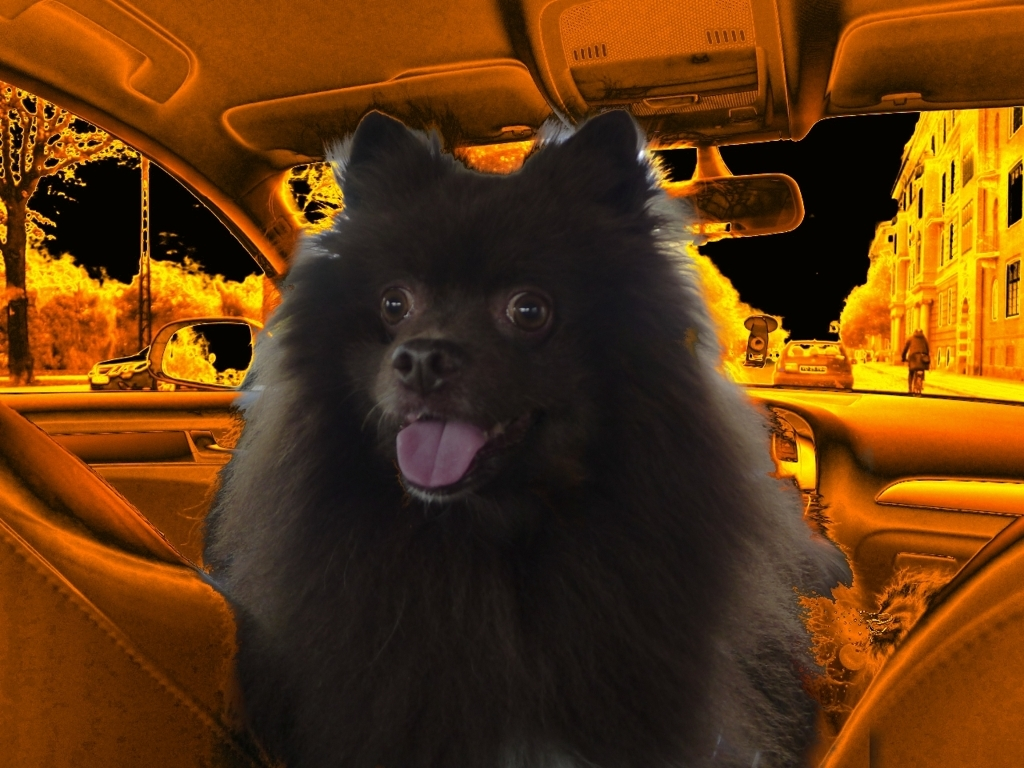What are some noticeable artifacts in this image?
A. sharpness
B. saturation
C. noise The most noticeable artifact in this image is the distortion of color or 'C. noise'. This is evident in the non-natural orange glow throughout the image, which is especially pronounced in what should be the neutral tones of the car's interior and the outside environment. The fact that the dog appears relatively less affected by the orange tone suggests selective color alteration or filtering, enhancing the contrast between the subject and the background. 